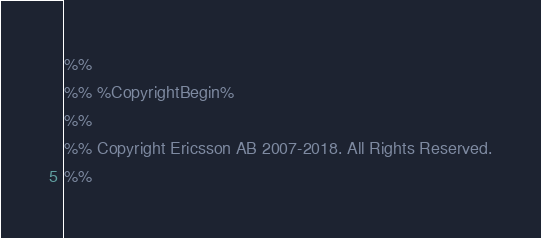Convert code to text. <code><loc_0><loc_0><loc_500><loc_500><_Erlang_>%%
%% %CopyrightBegin%
%%
%% Copyright Ericsson AB 2007-2018. All Rights Reserved.
%%</code> 